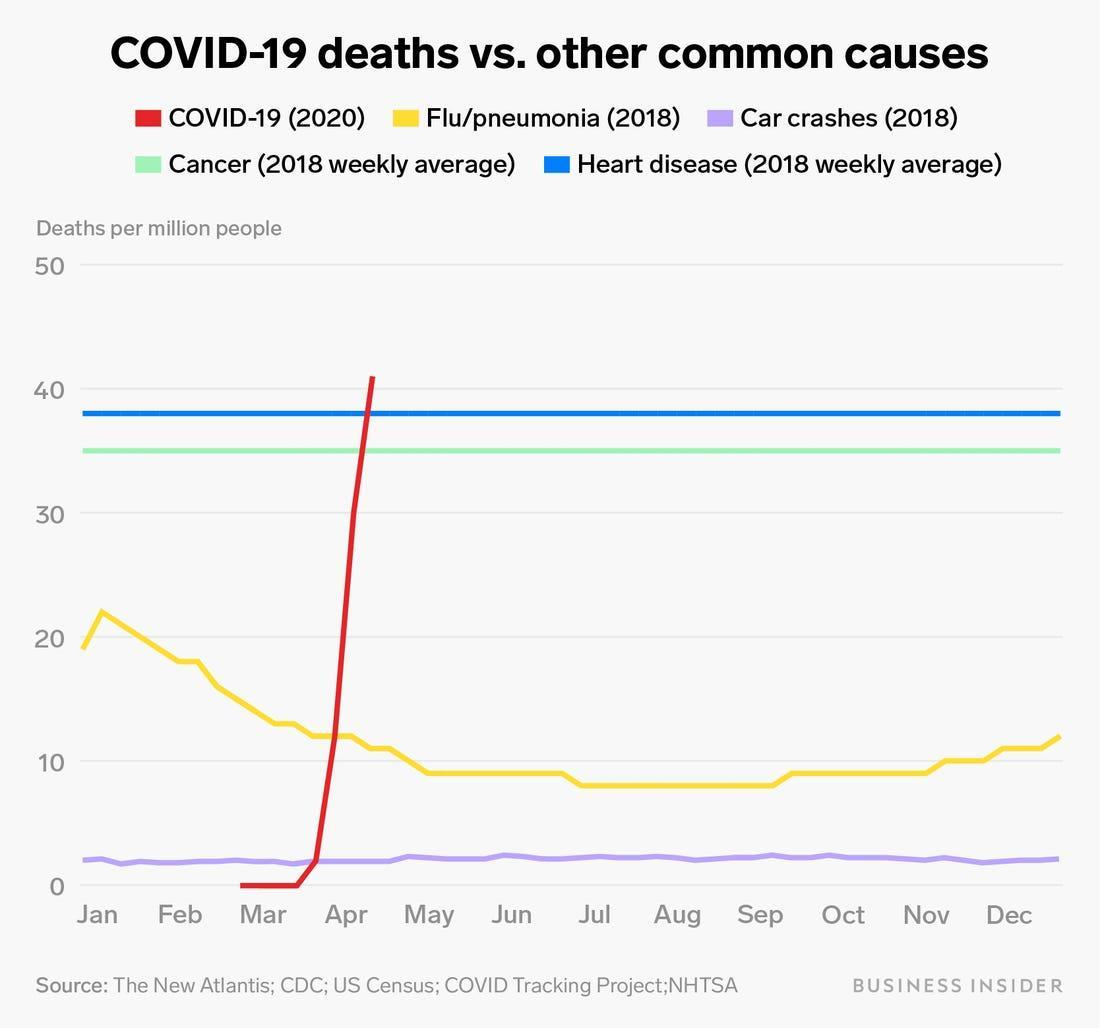In which month were the deaths due to COVID the highest
Answer the question with a short phrase. Mar, Apr What colour represents the COVID-19 deaths, red or green red What colour represents the heart disease deaths, blue or green blue Which disease has seen a sharp spike in January Flu/pneumonia Which causes of death has  seen a stable number from Jan to December Cancer, Heart Disease In which month did the death due to flu/pneumonia cross 20 per million Jan 